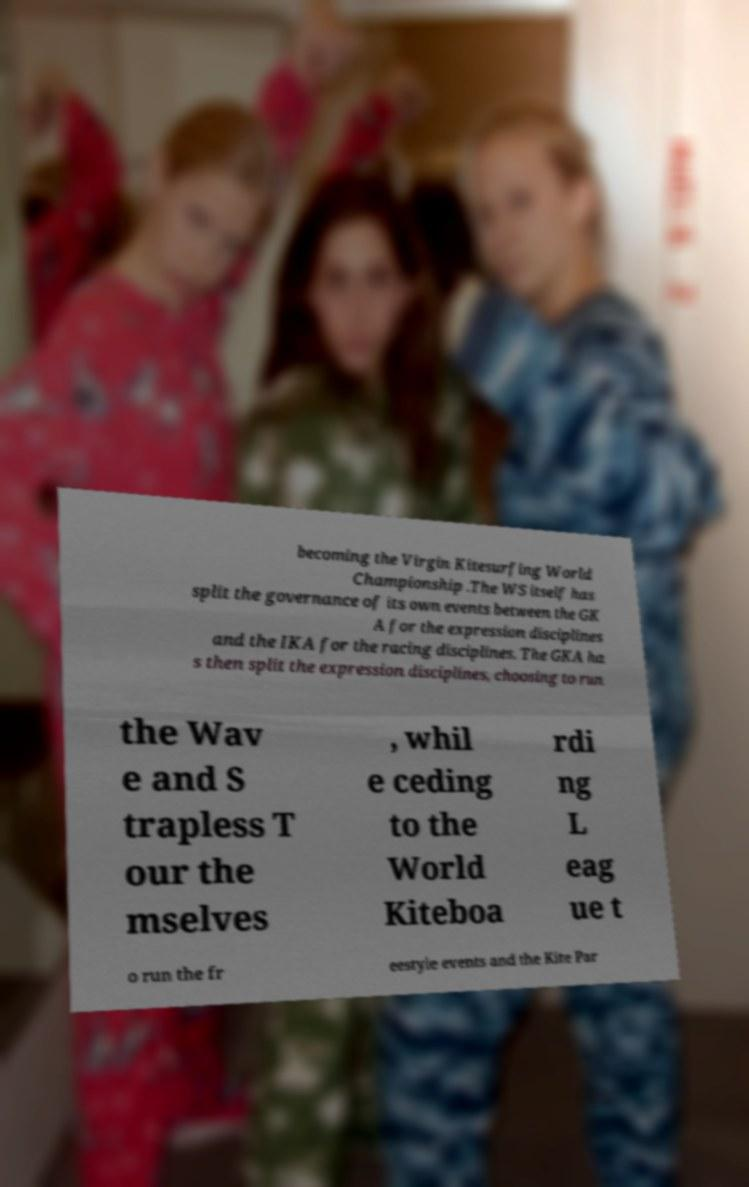I need the written content from this picture converted into text. Can you do that? becoming the Virgin Kitesurfing World Championship .The WS itself has split the governance of its own events between the GK A for the expression disciplines and the IKA for the racing disciplines. The GKA ha s then split the expression disciplines, choosing to run the Wav e and S trapless T our the mselves , whil e ceding to the World Kiteboa rdi ng L eag ue t o run the fr eestyle events and the Kite Par 